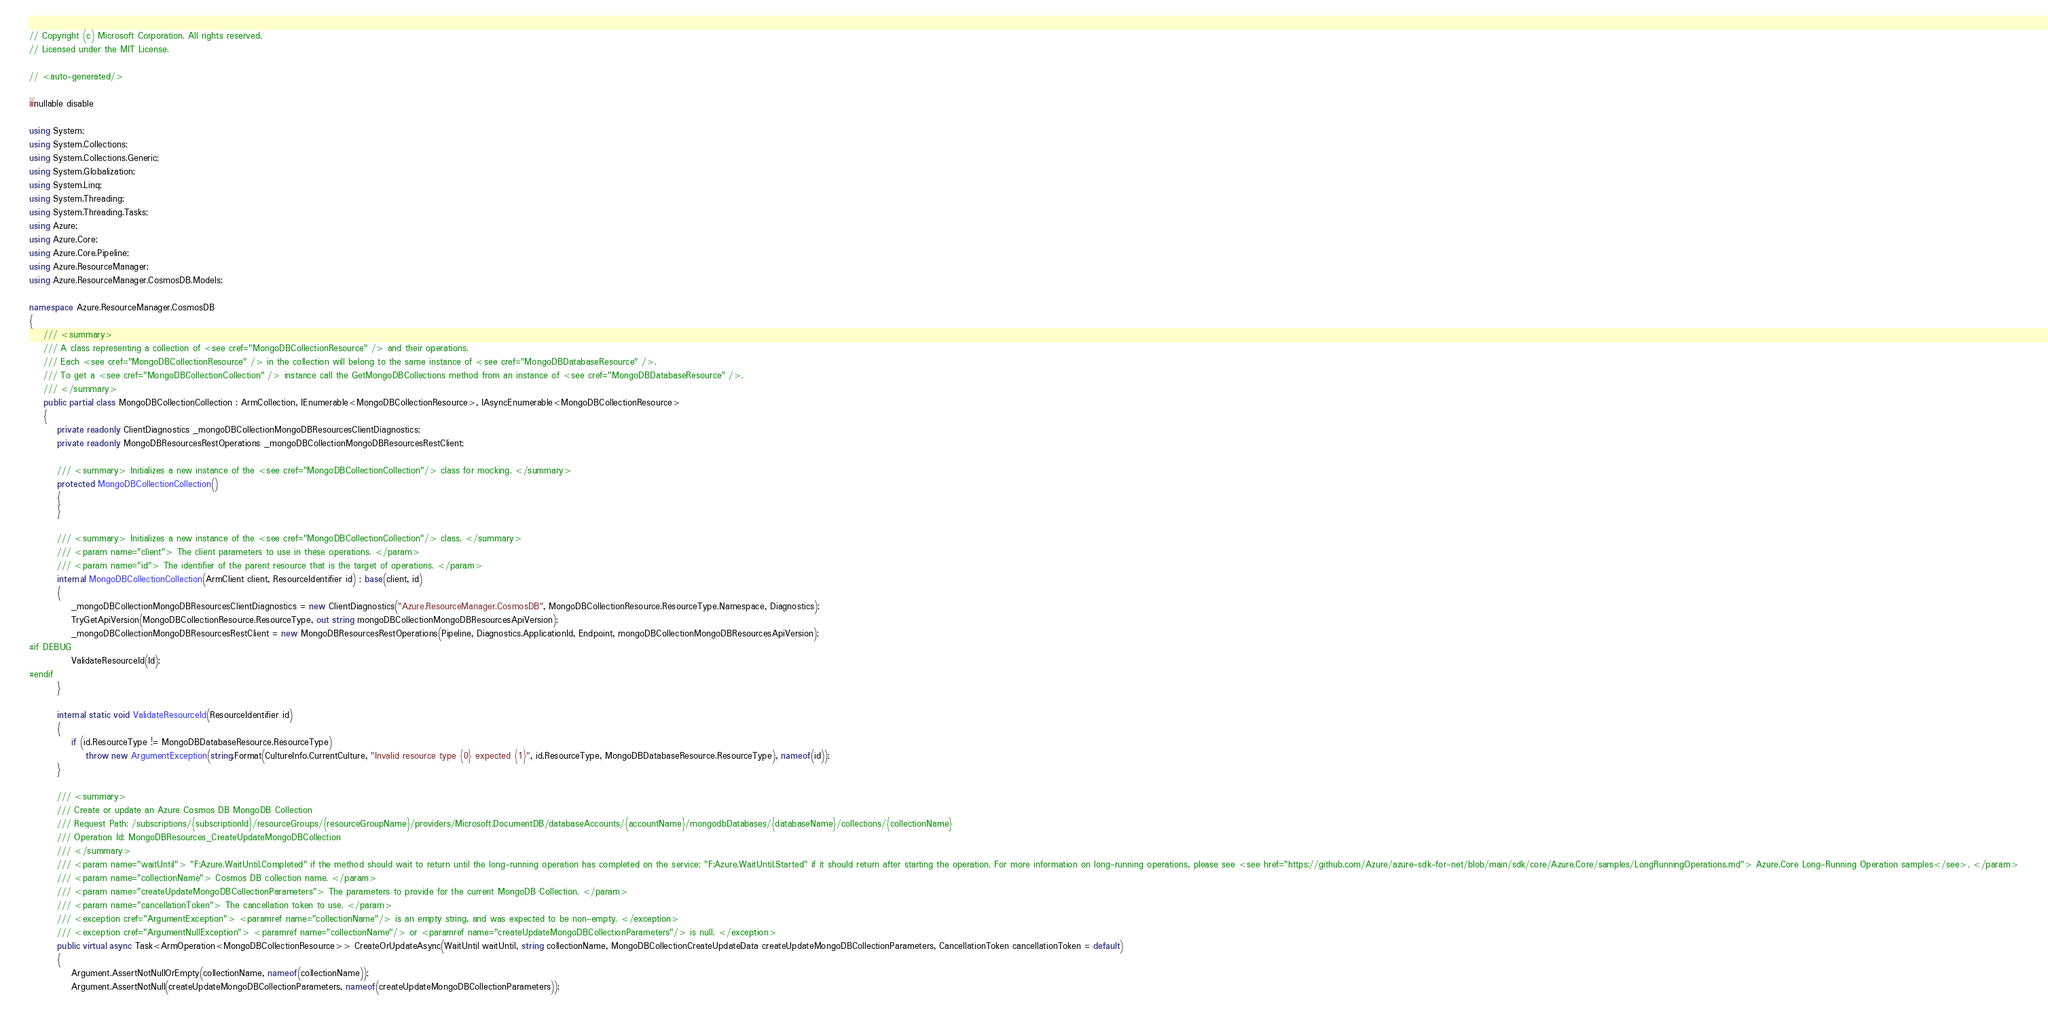<code> <loc_0><loc_0><loc_500><loc_500><_C#_>// Copyright (c) Microsoft Corporation. All rights reserved.
// Licensed under the MIT License.

// <auto-generated/>

#nullable disable

using System;
using System.Collections;
using System.Collections.Generic;
using System.Globalization;
using System.Linq;
using System.Threading;
using System.Threading.Tasks;
using Azure;
using Azure.Core;
using Azure.Core.Pipeline;
using Azure.ResourceManager;
using Azure.ResourceManager.CosmosDB.Models;

namespace Azure.ResourceManager.CosmosDB
{
    /// <summary>
    /// A class representing a collection of <see cref="MongoDBCollectionResource" /> and their operations.
    /// Each <see cref="MongoDBCollectionResource" /> in the collection will belong to the same instance of <see cref="MongoDBDatabaseResource" />.
    /// To get a <see cref="MongoDBCollectionCollection" /> instance call the GetMongoDBCollections method from an instance of <see cref="MongoDBDatabaseResource" />.
    /// </summary>
    public partial class MongoDBCollectionCollection : ArmCollection, IEnumerable<MongoDBCollectionResource>, IAsyncEnumerable<MongoDBCollectionResource>
    {
        private readonly ClientDiagnostics _mongoDBCollectionMongoDBResourcesClientDiagnostics;
        private readonly MongoDBResourcesRestOperations _mongoDBCollectionMongoDBResourcesRestClient;

        /// <summary> Initializes a new instance of the <see cref="MongoDBCollectionCollection"/> class for mocking. </summary>
        protected MongoDBCollectionCollection()
        {
        }

        /// <summary> Initializes a new instance of the <see cref="MongoDBCollectionCollection"/> class. </summary>
        /// <param name="client"> The client parameters to use in these operations. </param>
        /// <param name="id"> The identifier of the parent resource that is the target of operations. </param>
        internal MongoDBCollectionCollection(ArmClient client, ResourceIdentifier id) : base(client, id)
        {
            _mongoDBCollectionMongoDBResourcesClientDiagnostics = new ClientDiagnostics("Azure.ResourceManager.CosmosDB", MongoDBCollectionResource.ResourceType.Namespace, Diagnostics);
            TryGetApiVersion(MongoDBCollectionResource.ResourceType, out string mongoDBCollectionMongoDBResourcesApiVersion);
            _mongoDBCollectionMongoDBResourcesRestClient = new MongoDBResourcesRestOperations(Pipeline, Diagnostics.ApplicationId, Endpoint, mongoDBCollectionMongoDBResourcesApiVersion);
#if DEBUG
			ValidateResourceId(Id);
#endif
        }

        internal static void ValidateResourceId(ResourceIdentifier id)
        {
            if (id.ResourceType != MongoDBDatabaseResource.ResourceType)
                throw new ArgumentException(string.Format(CultureInfo.CurrentCulture, "Invalid resource type {0} expected {1}", id.ResourceType, MongoDBDatabaseResource.ResourceType), nameof(id));
        }

        /// <summary>
        /// Create or update an Azure Cosmos DB MongoDB Collection
        /// Request Path: /subscriptions/{subscriptionId}/resourceGroups/{resourceGroupName}/providers/Microsoft.DocumentDB/databaseAccounts/{accountName}/mongodbDatabases/{databaseName}/collections/{collectionName}
        /// Operation Id: MongoDBResources_CreateUpdateMongoDBCollection
        /// </summary>
        /// <param name="waitUntil"> "F:Azure.WaitUntil.Completed" if the method should wait to return until the long-running operation has completed on the service; "F:Azure.WaitUntil.Started" if it should return after starting the operation. For more information on long-running operations, please see <see href="https://github.com/Azure/azure-sdk-for-net/blob/main/sdk/core/Azure.Core/samples/LongRunningOperations.md"> Azure.Core Long-Running Operation samples</see>. </param>
        /// <param name="collectionName"> Cosmos DB collection name. </param>
        /// <param name="createUpdateMongoDBCollectionParameters"> The parameters to provide for the current MongoDB Collection. </param>
        /// <param name="cancellationToken"> The cancellation token to use. </param>
        /// <exception cref="ArgumentException"> <paramref name="collectionName"/> is an empty string, and was expected to be non-empty. </exception>
        /// <exception cref="ArgumentNullException"> <paramref name="collectionName"/> or <paramref name="createUpdateMongoDBCollectionParameters"/> is null. </exception>
        public virtual async Task<ArmOperation<MongoDBCollectionResource>> CreateOrUpdateAsync(WaitUntil waitUntil, string collectionName, MongoDBCollectionCreateUpdateData createUpdateMongoDBCollectionParameters, CancellationToken cancellationToken = default)
        {
            Argument.AssertNotNullOrEmpty(collectionName, nameof(collectionName));
            Argument.AssertNotNull(createUpdateMongoDBCollectionParameters, nameof(createUpdateMongoDBCollectionParameters));
</code> 